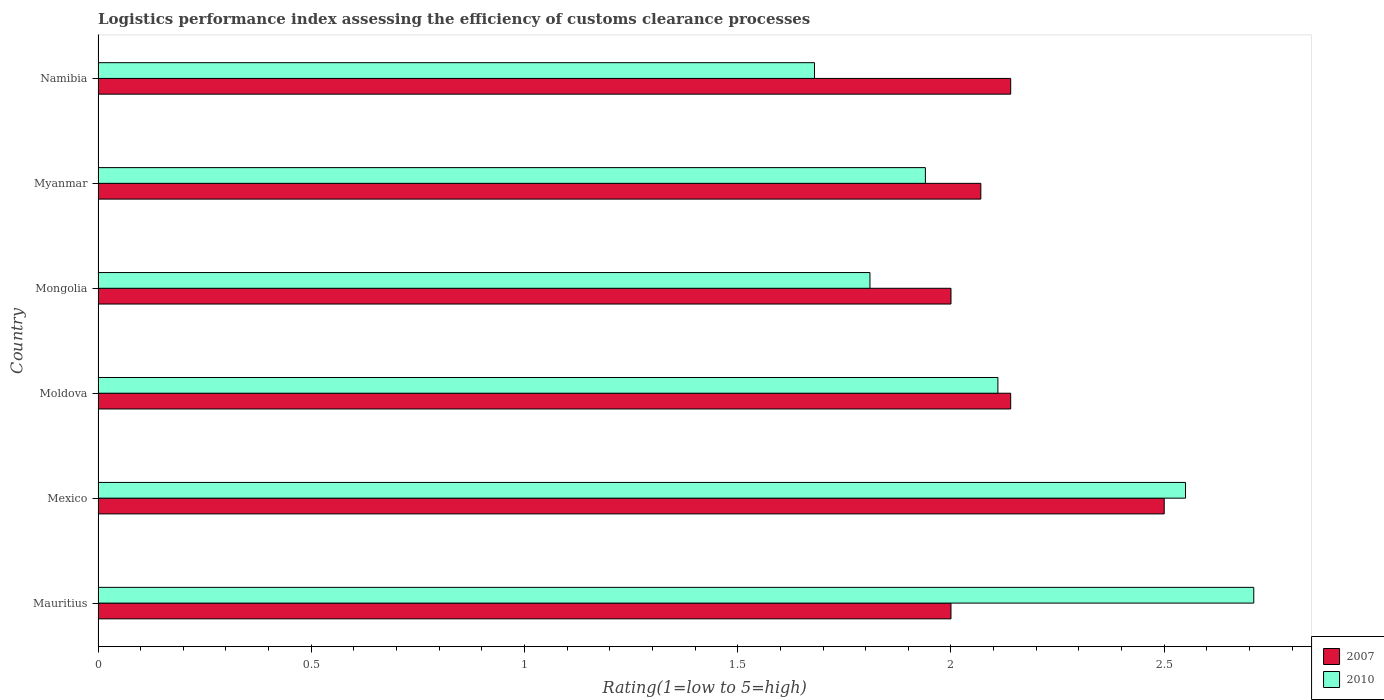How many different coloured bars are there?
Give a very brief answer. 2. Are the number of bars per tick equal to the number of legend labels?
Provide a short and direct response. Yes. Are the number of bars on each tick of the Y-axis equal?
Give a very brief answer. Yes. What is the label of the 2nd group of bars from the top?
Your answer should be very brief. Myanmar. In how many cases, is the number of bars for a given country not equal to the number of legend labels?
Your response must be concise. 0. What is the Logistic performance index in 2007 in Moldova?
Your answer should be compact. 2.14. Across all countries, what is the maximum Logistic performance index in 2007?
Offer a very short reply. 2.5. Across all countries, what is the minimum Logistic performance index in 2007?
Offer a very short reply. 2. In which country was the Logistic performance index in 2007 minimum?
Your answer should be compact. Mauritius. What is the total Logistic performance index in 2010 in the graph?
Provide a short and direct response. 12.8. What is the difference between the Logistic performance index in 2007 in Moldova and the Logistic performance index in 2010 in Mauritius?
Offer a terse response. -0.57. What is the average Logistic performance index in 2007 per country?
Provide a short and direct response. 2.14. What is the difference between the Logistic performance index in 2010 and Logistic performance index in 2007 in Myanmar?
Your answer should be very brief. -0.13. What is the ratio of the Logistic performance index in 2010 in Moldova to that in Myanmar?
Provide a succinct answer. 1.09. Is the difference between the Logistic performance index in 2010 in Mexico and Namibia greater than the difference between the Logistic performance index in 2007 in Mexico and Namibia?
Offer a very short reply. Yes. What is the difference between the highest and the second highest Logistic performance index in 2007?
Provide a short and direct response. 0.36. What is the difference between the highest and the lowest Logistic performance index in 2007?
Your answer should be very brief. 0.5. How many countries are there in the graph?
Provide a short and direct response. 6. Does the graph contain any zero values?
Your answer should be very brief. No. Where does the legend appear in the graph?
Ensure brevity in your answer.  Bottom right. What is the title of the graph?
Your answer should be very brief. Logistics performance index assessing the efficiency of customs clearance processes. What is the label or title of the X-axis?
Keep it short and to the point. Rating(1=low to 5=high). What is the Rating(1=low to 5=high) of 2010 in Mauritius?
Offer a very short reply. 2.71. What is the Rating(1=low to 5=high) in 2010 in Mexico?
Provide a succinct answer. 2.55. What is the Rating(1=low to 5=high) in 2007 in Moldova?
Offer a terse response. 2.14. What is the Rating(1=low to 5=high) in 2010 in Moldova?
Your response must be concise. 2.11. What is the Rating(1=low to 5=high) in 2010 in Mongolia?
Your answer should be compact. 1.81. What is the Rating(1=low to 5=high) of 2007 in Myanmar?
Your response must be concise. 2.07. What is the Rating(1=low to 5=high) of 2010 in Myanmar?
Provide a succinct answer. 1.94. What is the Rating(1=low to 5=high) of 2007 in Namibia?
Make the answer very short. 2.14. What is the Rating(1=low to 5=high) of 2010 in Namibia?
Your answer should be very brief. 1.68. Across all countries, what is the maximum Rating(1=low to 5=high) in 2007?
Ensure brevity in your answer.  2.5. Across all countries, what is the maximum Rating(1=low to 5=high) in 2010?
Your response must be concise. 2.71. Across all countries, what is the minimum Rating(1=low to 5=high) of 2007?
Make the answer very short. 2. Across all countries, what is the minimum Rating(1=low to 5=high) in 2010?
Your answer should be very brief. 1.68. What is the total Rating(1=low to 5=high) of 2007 in the graph?
Provide a short and direct response. 12.85. What is the difference between the Rating(1=low to 5=high) in 2010 in Mauritius and that in Mexico?
Provide a succinct answer. 0.16. What is the difference between the Rating(1=low to 5=high) of 2007 in Mauritius and that in Moldova?
Make the answer very short. -0.14. What is the difference between the Rating(1=low to 5=high) in 2010 in Mauritius and that in Moldova?
Provide a succinct answer. 0.6. What is the difference between the Rating(1=low to 5=high) of 2007 in Mauritius and that in Mongolia?
Provide a succinct answer. 0. What is the difference between the Rating(1=low to 5=high) of 2010 in Mauritius and that in Mongolia?
Ensure brevity in your answer.  0.9. What is the difference between the Rating(1=low to 5=high) of 2007 in Mauritius and that in Myanmar?
Provide a short and direct response. -0.07. What is the difference between the Rating(1=low to 5=high) of 2010 in Mauritius and that in Myanmar?
Your answer should be very brief. 0.77. What is the difference between the Rating(1=low to 5=high) in 2007 in Mauritius and that in Namibia?
Offer a very short reply. -0.14. What is the difference between the Rating(1=low to 5=high) in 2010 in Mauritius and that in Namibia?
Offer a terse response. 1.03. What is the difference between the Rating(1=low to 5=high) in 2007 in Mexico and that in Moldova?
Provide a succinct answer. 0.36. What is the difference between the Rating(1=low to 5=high) in 2010 in Mexico and that in Moldova?
Your answer should be very brief. 0.44. What is the difference between the Rating(1=low to 5=high) in 2010 in Mexico and that in Mongolia?
Make the answer very short. 0.74. What is the difference between the Rating(1=low to 5=high) of 2007 in Mexico and that in Myanmar?
Keep it short and to the point. 0.43. What is the difference between the Rating(1=low to 5=high) of 2010 in Mexico and that in Myanmar?
Give a very brief answer. 0.61. What is the difference between the Rating(1=low to 5=high) in 2007 in Mexico and that in Namibia?
Your answer should be compact. 0.36. What is the difference between the Rating(1=low to 5=high) of 2010 in Mexico and that in Namibia?
Ensure brevity in your answer.  0.87. What is the difference between the Rating(1=low to 5=high) of 2007 in Moldova and that in Mongolia?
Keep it short and to the point. 0.14. What is the difference between the Rating(1=low to 5=high) in 2010 in Moldova and that in Mongolia?
Offer a terse response. 0.3. What is the difference between the Rating(1=low to 5=high) in 2007 in Moldova and that in Myanmar?
Ensure brevity in your answer.  0.07. What is the difference between the Rating(1=low to 5=high) of 2010 in Moldova and that in Myanmar?
Give a very brief answer. 0.17. What is the difference between the Rating(1=low to 5=high) in 2010 in Moldova and that in Namibia?
Offer a very short reply. 0.43. What is the difference between the Rating(1=low to 5=high) of 2007 in Mongolia and that in Myanmar?
Provide a succinct answer. -0.07. What is the difference between the Rating(1=low to 5=high) in 2010 in Mongolia and that in Myanmar?
Keep it short and to the point. -0.13. What is the difference between the Rating(1=low to 5=high) of 2007 in Mongolia and that in Namibia?
Keep it short and to the point. -0.14. What is the difference between the Rating(1=low to 5=high) in 2010 in Mongolia and that in Namibia?
Provide a short and direct response. 0.13. What is the difference between the Rating(1=low to 5=high) of 2007 in Myanmar and that in Namibia?
Provide a short and direct response. -0.07. What is the difference between the Rating(1=low to 5=high) of 2010 in Myanmar and that in Namibia?
Offer a very short reply. 0.26. What is the difference between the Rating(1=low to 5=high) of 2007 in Mauritius and the Rating(1=low to 5=high) of 2010 in Mexico?
Your answer should be very brief. -0.55. What is the difference between the Rating(1=low to 5=high) of 2007 in Mauritius and the Rating(1=low to 5=high) of 2010 in Moldova?
Your response must be concise. -0.11. What is the difference between the Rating(1=low to 5=high) in 2007 in Mauritius and the Rating(1=low to 5=high) in 2010 in Mongolia?
Ensure brevity in your answer.  0.19. What is the difference between the Rating(1=low to 5=high) of 2007 in Mauritius and the Rating(1=low to 5=high) of 2010 in Namibia?
Your answer should be compact. 0.32. What is the difference between the Rating(1=low to 5=high) in 2007 in Mexico and the Rating(1=low to 5=high) in 2010 in Moldova?
Your response must be concise. 0.39. What is the difference between the Rating(1=low to 5=high) in 2007 in Mexico and the Rating(1=low to 5=high) in 2010 in Mongolia?
Your response must be concise. 0.69. What is the difference between the Rating(1=low to 5=high) in 2007 in Mexico and the Rating(1=low to 5=high) in 2010 in Myanmar?
Your answer should be very brief. 0.56. What is the difference between the Rating(1=low to 5=high) in 2007 in Mexico and the Rating(1=low to 5=high) in 2010 in Namibia?
Your response must be concise. 0.82. What is the difference between the Rating(1=low to 5=high) in 2007 in Moldova and the Rating(1=low to 5=high) in 2010 in Mongolia?
Your answer should be compact. 0.33. What is the difference between the Rating(1=low to 5=high) of 2007 in Moldova and the Rating(1=low to 5=high) of 2010 in Myanmar?
Your answer should be compact. 0.2. What is the difference between the Rating(1=low to 5=high) of 2007 in Moldova and the Rating(1=low to 5=high) of 2010 in Namibia?
Offer a very short reply. 0.46. What is the difference between the Rating(1=low to 5=high) in 2007 in Mongolia and the Rating(1=low to 5=high) in 2010 in Namibia?
Keep it short and to the point. 0.32. What is the difference between the Rating(1=low to 5=high) of 2007 in Myanmar and the Rating(1=low to 5=high) of 2010 in Namibia?
Your answer should be compact. 0.39. What is the average Rating(1=low to 5=high) in 2007 per country?
Your answer should be very brief. 2.14. What is the average Rating(1=low to 5=high) in 2010 per country?
Offer a very short reply. 2.13. What is the difference between the Rating(1=low to 5=high) in 2007 and Rating(1=low to 5=high) in 2010 in Mauritius?
Your answer should be compact. -0.71. What is the difference between the Rating(1=low to 5=high) in 2007 and Rating(1=low to 5=high) in 2010 in Moldova?
Make the answer very short. 0.03. What is the difference between the Rating(1=low to 5=high) in 2007 and Rating(1=low to 5=high) in 2010 in Mongolia?
Give a very brief answer. 0.19. What is the difference between the Rating(1=low to 5=high) of 2007 and Rating(1=low to 5=high) of 2010 in Myanmar?
Your answer should be very brief. 0.13. What is the difference between the Rating(1=low to 5=high) in 2007 and Rating(1=low to 5=high) in 2010 in Namibia?
Offer a terse response. 0.46. What is the ratio of the Rating(1=low to 5=high) in 2010 in Mauritius to that in Mexico?
Your answer should be very brief. 1.06. What is the ratio of the Rating(1=low to 5=high) in 2007 in Mauritius to that in Moldova?
Give a very brief answer. 0.93. What is the ratio of the Rating(1=low to 5=high) in 2010 in Mauritius to that in Moldova?
Your answer should be very brief. 1.28. What is the ratio of the Rating(1=low to 5=high) of 2007 in Mauritius to that in Mongolia?
Offer a very short reply. 1. What is the ratio of the Rating(1=low to 5=high) of 2010 in Mauritius to that in Mongolia?
Provide a short and direct response. 1.5. What is the ratio of the Rating(1=low to 5=high) of 2007 in Mauritius to that in Myanmar?
Give a very brief answer. 0.97. What is the ratio of the Rating(1=low to 5=high) of 2010 in Mauritius to that in Myanmar?
Your answer should be very brief. 1.4. What is the ratio of the Rating(1=low to 5=high) in 2007 in Mauritius to that in Namibia?
Your response must be concise. 0.93. What is the ratio of the Rating(1=low to 5=high) of 2010 in Mauritius to that in Namibia?
Your answer should be compact. 1.61. What is the ratio of the Rating(1=low to 5=high) of 2007 in Mexico to that in Moldova?
Provide a short and direct response. 1.17. What is the ratio of the Rating(1=low to 5=high) of 2010 in Mexico to that in Moldova?
Your answer should be very brief. 1.21. What is the ratio of the Rating(1=low to 5=high) of 2007 in Mexico to that in Mongolia?
Provide a short and direct response. 1.25. What is the ratio of the Rating(1=low to 5=high) in 2010 in Mexico to that in Mongolia?
Keep it short and to the point. 1.41. What is the ratio of the Rating(1=low to 5=high) in 2007 in Mexico to that in Myanmar?
Provide a short and direct response. 1.21. What is the ratio of the Rating(1=low to 5=high) in 2010 in Mexico to that in Myanmar?
Give a very brief answer. 1.31. What is the ratio of the Rating(1=low to 5=high) in 2007 in Mexico to that in Namibia?
Offer a very short reply. 1.17. What is the ratio of the Rating(1=low to 5=high) of 2010 in Mexico to that in Namibia?
Make the answer very short. 1.52. What is the ratio of the Rating(1=low to 5=high) of 2007 in Moldova to that in Mongolia?
Ensure brevity in your answer.  1.07. What is the ratio of the Rating(1=low to 5=high) of 2010 in Moldova to that in Mongolia?
Give a very brief answer. 1.17. What is the ratio of the Rating(1=low to 5=high) of 2007 in Moldova to that in Myanmar?
Ensure brevity in your answer.  1.03. What is the ratio of the Rating(1=low to 5=high) in 2010 in Moldova to that in Myanmar?
Provide a short and direct response. 1.09. What is the ratio of the Rating(1=low to 5=high) of 2007 in Moldova to that in Namibia?
Offer a very short reply. 1. What is the ratio of the Rating(1=low to 5=high) of 2010 in Moldova to that in Namibia?
Provide a short and direct response. 1.26. What is the ratio of the Rating(1=low to 5=high) in 2007 in Mongolia to that in Myanmar?
Keep it short and to the point. 0.97. What is the ratio of the Rating(1=low to 5=high) of 2010 in Mongolia to that in Myanmar?
Your answer should be compact. 0.93. What is the ratio of the Rating(1=low to 5=high) of 2007 in Mongolia to that in Namibia?
Your response must be concise. 0.93. What is the ratio of the Rating(1=low to 5=high) of 2010 in Mongolia to that in Namibia?
Your answer should be very brief. 1.08. What is the ratio of the Rating(1=low to 5=high) in 2007 in Myanmar to that in Namibia?
Ensure brevity in your answer.  0.97. What is the ratio of the Rating(1=low to 5=high) of 2010 in Myanmar to that in Namibia?
Offer a terse response. 1.15. What is the difference between the highest and the second highest Rating(1=low to 5=high) of 2007?
Your response must be concise. 0.36. What is the difference between the highest and the second highest Rating(1=low to 5=high) in 2010?
Offer a very short reply. 0.16. What is the difference between the highest and the lowest Rating(1=low to 5=high) of 2010?
Offer a terse response. 1.03. 